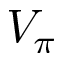Convert formula to latex. <formula><loc_0><loc_0><loc_500><loc_500>V _ { \pi }</formula> 